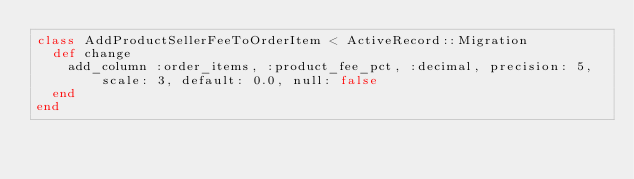<code> <loc_0><loc_0><loc_500><loc_500><_Ruby_>class AddProductSellerFeeToOrderItem < ActiveRecord::Migration
  def change
    add_column :order_items, :product_fee_pct, :decimal, precision: 5, scale: 3, default: 0.0, null: false
  end
end
</code> 